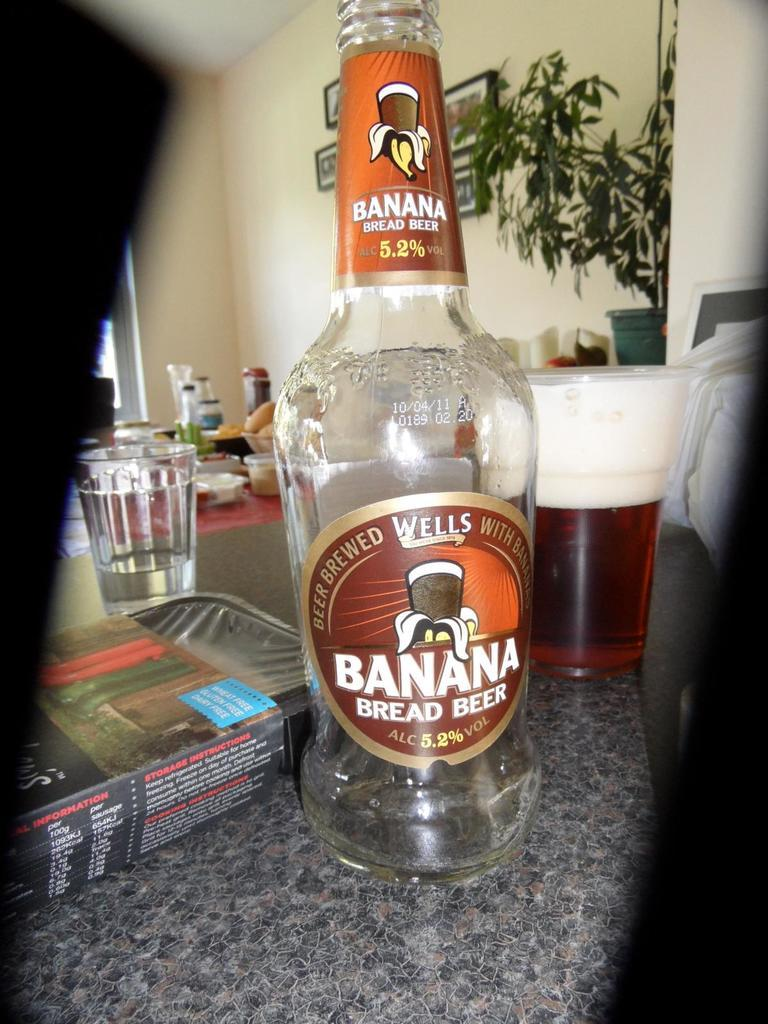<image>
Render a clear and concise summary of the photo. A bottle of Banana bread beer is on a counter by a tray and mug. 